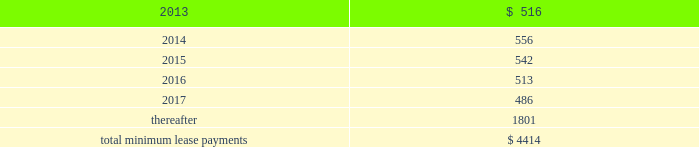Other off-balance sheet commitments lease commitments the company leases various equipment and facilities , including retail space , under noncancelable operating lease arrangements .
The company does not currently utilize any other off-balance sheet financing arrangements .
The major facility leases are typically for terms not exceeding 10 years and generally provide renewal options for terms not exceeding five additional years .
Leases for retail space are for terms ranging from five to 20 years , the majority of which are for 10 years , and often contain multi-year renewal options .
As of september 29 , 2012 , the company 2019s total future minimum lease payments under noncancelable operating leases were $ 4.4 billion , of which $ 3.1 billion related to leases for retail space .
Rent expense under all operating leases , including both cancelable and noncancelable leases , was $ 488 million , $ 338 million and $ 271 million in 2012 , 2011 and 2010 , respectively .
Future minimum lease payments under noncancelable operating leases having remaining terms in excess of one year as of september 29 , 2012 , are as follows ( in millions ) : .
Other commitments as of september 29 , 2012 , the company had outstanding off-balance sheet third-party manufacturing commitments and component purchase commitments of $ 21.1 billion .
In addition to the off-balance sheet commitments mentioned above , the company had outstanding obligations of $ 988 million as of september 29 , 2012 , which were comprised mainly of commitments to acquire capital assets , including product tooling and manufacturing process equipment , and commitments related to advertising , research and development , internet and telecommunications services and other obligations .
Contingencies the company is subject to various legal proceedings and claims that have arisen in the ordinary course of business and have not been fully adjudicated , certain of which are discussed in part i , item 3 of this form 10-k under the heading 201clegal proceedings 201d and in part i , item 1a of this form 10-k under the heading 201crisk factors . 201d in the opinion of management , there was not at least a reasonable possibility the company may have incurred a material loss , or a material loss in excess of a recorded accrual , with respect to loss contingencies .
However , the outcome of litigation is inherently uncertain .
Therefore , although management considers the likelihood of such an outcome to be remote , if one or more of these legal matters were resolved against the company in a reporting period for amounts in excess of management 2019s expectations , the company 2019s consolidated financial statements for that reporting period could be materially adversely affected .
Apple inc .
Vs samsung electronics co. , ltd , et al .
On august 24 , 2012 , a jury returned a verdict awarding the company $ 1.05 billion in its lawsuit against samsung electronics and affiliated parties in the united states district court , northern district of california , san jose division .
Because the award is subject to entry of final judgment and may be subject to appeal , the company has not recognized the award in its consolidated financial statements for the year ended september 29 , 2012. .
What was the percentage change in rent expense under operating leases from 2011 to 2012? 
Computations: ((488 - 338) / 338)
Answer: 0.44379. 